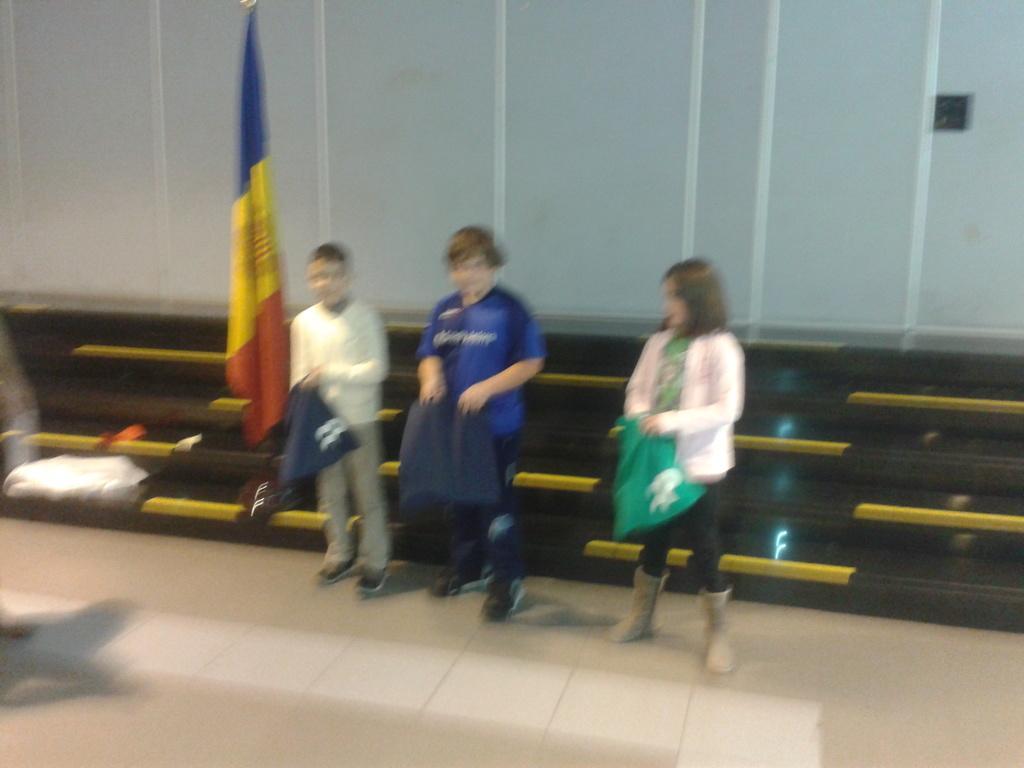Describe this image in one or two sentences. In this image we can see persons standing on the floor and holding clothes in their hands. Beside the persons we can see a flag and walls in the background. 